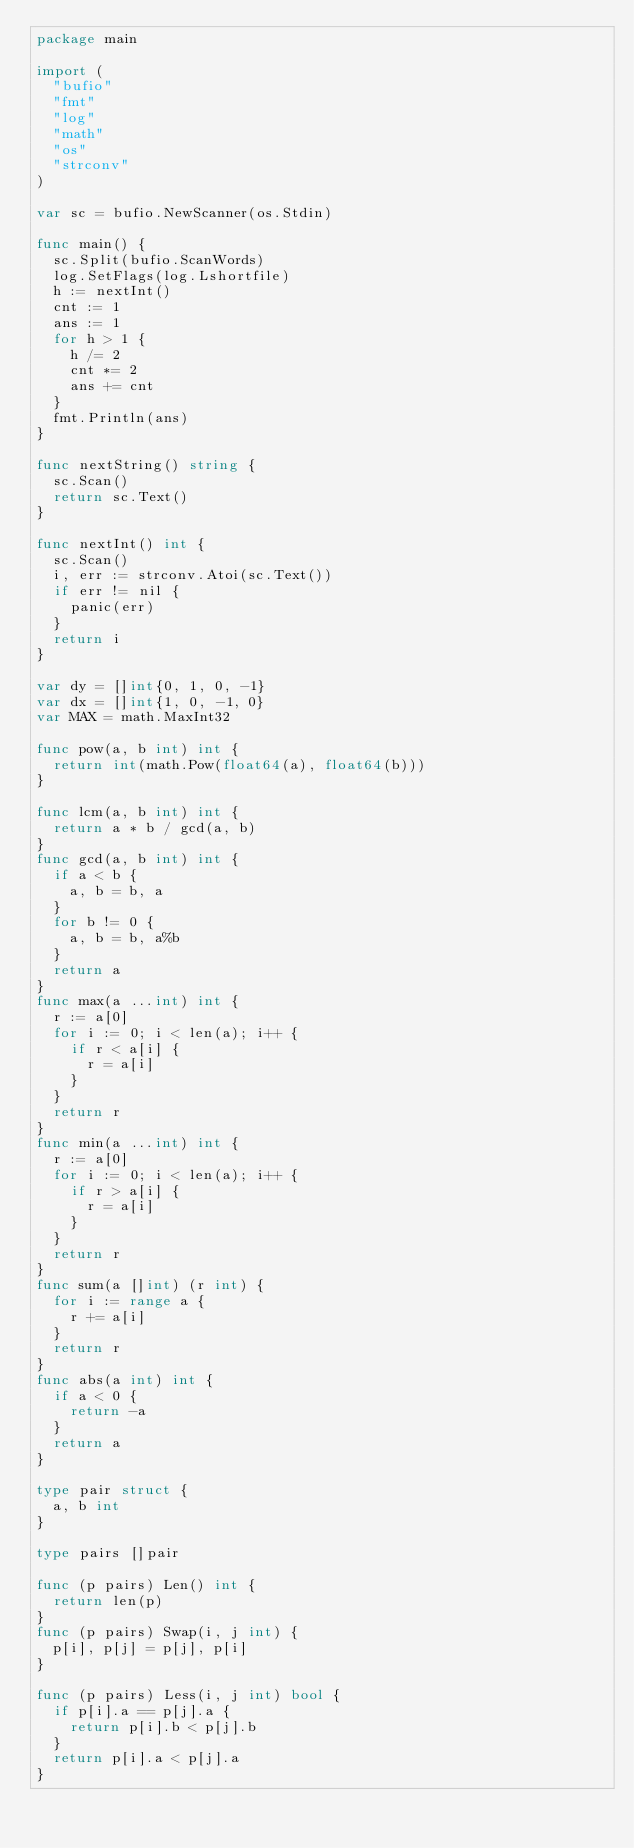Convert code to text. <code><loc_0><loc_0><loc_500><loc_500><_Go_>package main

import (
	"bufio"
	"fmt"
	"log"
	"math"
	"os"
	"strconv"
)

var sc = bufio.NewScanner(os.Stdin)

func main() {
	sc.Split(bufio.ScanWords)
	log.SetFlags(log.Lshortfile)
	h := nextInt()
	cnt := 1
	ans := 1
	for h > 1 {
		h /= 2
		cnt *= 2
		ans += cnt
	}
	fmt.Println(ans)
}

func nextString() string {
	sc.Scan()
	return sc.Text()
}

func nextInt() int {
	sc.Scan()
	i, err := strconv.Atoi(sc.Text())
	if err != nil {
		panic(err)
	}
	return i
}

var dy = []int{0, 1, 0, -1}
var dx = []int{1, 0, -1, 0}
var MAX = math.MaxInt32

func pow(a, b int) int {
	return int(math.Pow(float64(a), float64(b)))
}

func lcm(a, b int) int {
	return a * b / gcd(a, b)
}
func gcd(a, b int) int {
	if a < b {
		a, b = b, a
	}
	for b != 0 {
		a, b = b, a%b
	}
	return a
}
func max(a ...int) int {
	r := a[0]
	for i := 0; i < len(a); i++ {
		if r < a[i] {
			r = a[i]
		}
	}
	return r
}
func min(a ...int) int {
	r := a[0]
	for i := 0; i < len(a); i++ {
		if r > a[i] {
			r = a[i]
		}
	}
	return r
}
func sum(a []int) (r int) {
	for i := range a {
		r += a[i]
	}
	return r
}
func abs(a int) int {
	if a < 0 {
		return -a
	}
	return a
}

type pair struct {
	a, b int
}

type pairs []pair

func (p pairs) Len() int {
	return len(p)
}
func (p pairs) Swap(i, j int) {
	p[i], p[j] = p[j], p[i]
}

func (p pairs) Less(i, j int) bool {
	if p[i].a == p[j].a {
		return p[i].b < p[j].b
	}
	return p[i].a < p[j].a
}
</code> 